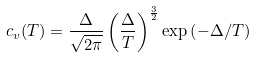Convert formula to latex. <formula><loc_0><loc_0><loc_500><loc_500>c _ { v } ( T ) = \frac { \Delta } { \sqrt { 2 \pi } } \left ( \frac { \Delta } { T } \right ) ^ { \frac { 3 } { 2 } } \exp { \left ( - \Delta / T \right ) }</formula> 